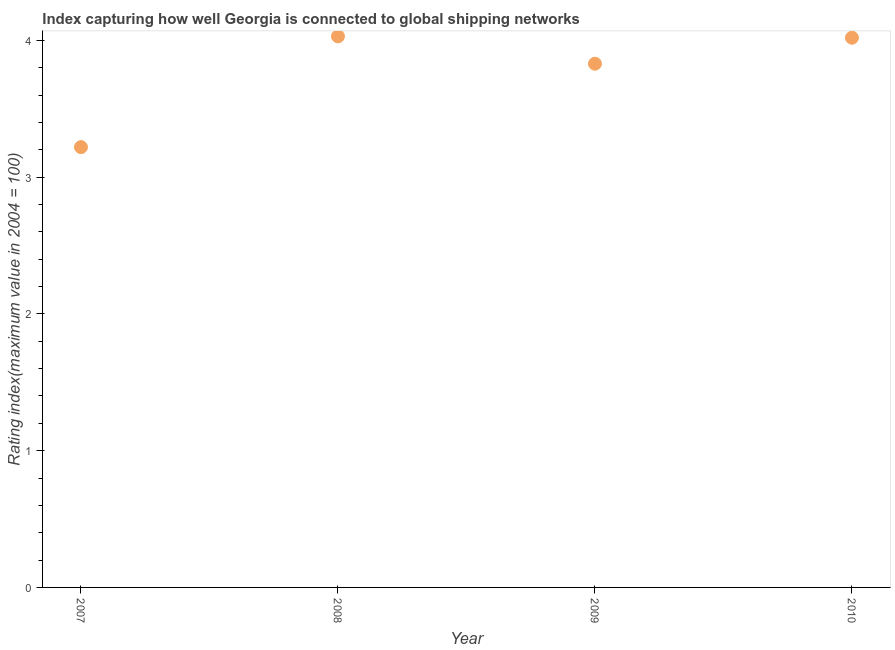What is the liner shipping connectivity index in 2008?
Provide a succinct answer. 4.03. Across all years, what is the maximum liner shipping connectivity index?
Your answer should be compact. 4.03. Across all years, what is the minimum liner shipping connectivity index?
Offer a very short reply. 3.22. What is the sum of the liner shipping connectivity index?
Provide a short and direct response. 15.1. What is the difference between the liner shipping connectivity index in 2008 and 2010?
Your answer should be compact. 0.01. What is the average liner shipping connectivity index per year?
Offer a very short reply. 3.77. What is the median liner shipping connectivity index?
Your response must be concise. 3.92. What is the ratio of the liner shipping connectivity index in 2007 to that in 2008?
Offer a very short reply. 0.8. Is the liner shipping connectivity index in 2007 less than that in 2010?
Offer a terse response. Yes. Is the difference between the liner shipping connectivity index in 2007 and 2010 greater than the difference between any two years?
Your response must be concise. No. What is the difference between the highest and the second highest liner shipping connectivity index?
Make the answer very short. 0.01. What is the difference between the highest and the lowest liner shipping connectivity index?
Keep it short and to the point. 0.81. Does the liner shipping connectivity index monotonically increase over the years?
Your answer should be compact. No. How many years are there in the graph?
Your response must be concise. 4. Are the values on the major ticks of Y-axis written in scientific E-notation?
Give a very brief answer. No. Does the graph contain any zero values?
Offer a very short reply. No. What is the title of the graph?
Your answer should be very brief. Index capturing how well Georgia is connected to global shipping networks. What is the label or title of the X-axis?
Your response must be concise. Year. What is the label or title of the Y-axis?
Offer a terse response. Rating index(maximum value in 2004 = 100). What is the Rating index(maximum value in 2004 = 100) in 2007?
Ensure brevity in your answer.  3.22. What is the Rating index(maximum value in 2004 = 100) in 2008?
Your response must be concise. 4.03. What is the Rating index(maximum value in 2004 = 100) in 2009?
Provide a short and direct response. 3.83. What is the Rating index(maximum value in 2004 = 100) in 2010?
Ensure brevity in your answer.  4.02. What is the difference between the Rating index(maximum value in 2004 = 100) in 2007 and 2008?
Your response must be concise. -0.81. What is the difference between the Rating index(maximum value in 2004 = 100) in 2007 and 2009?
Give a very brief answer. -0.61. What is the difference between the Rating index(maximum value in 2004 = 100) in 2008 and 2009?
Your answer should be very brief. 0.2. What is the difference between the Rating index(maximum value in 2004 = 100) in 2009 and 2010?
Ensure brevity in your answer.  -0.19. What is the ratio of the Rating index(maximum value in 2004 = 100) in 2007 to that in 2008?
Provide a short and direct response. 0.8. What is the ratio of the Rating index(maximum value in 2004 = 100) in 2007 to that in 2009?
Provide a succinct answer. 0.84. What is the ratio of the Rating index(maximum value in 2004 = 100) in 2007 to that in 2010?
Ensure brevity in your answer.  0.8. What is the ratio of the Rating index(maximum value in 2004 = 100) in 2008 to that in 2009?
Ensure brevity in your answer.  1.05. What is the ratio of the Rating index(maximum value in 2004 = 100) in 2009 to that in 2010?
Provide a short and direct response. 0.95. 